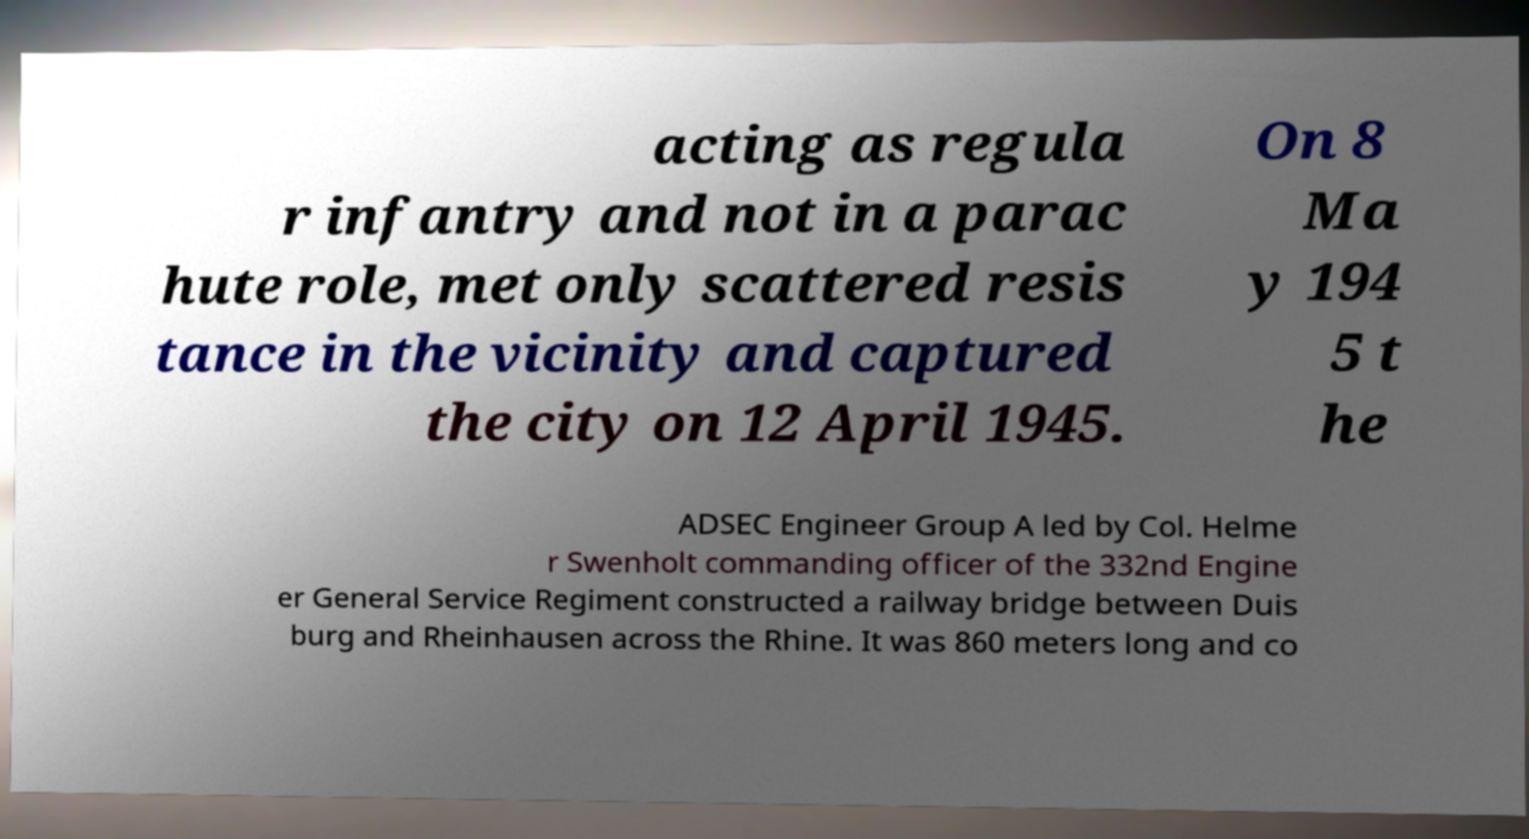Could you assist in decoding the text presented in this image and type it out clearly? acting as regula r infantry and not in a parac hute role, met only scattered resis tance in the vicinity and captured the city on 12 April 1945. On 8 Ma y 194 5 t he ADSEC Engineer Group A led by Col. Helme r Swenholt commanding officer of the 332nd Engine er General Service Regiment constructed a railway bridge between Duis burg and Rheinhausen across the Rhine. It was 860 meters long and co 